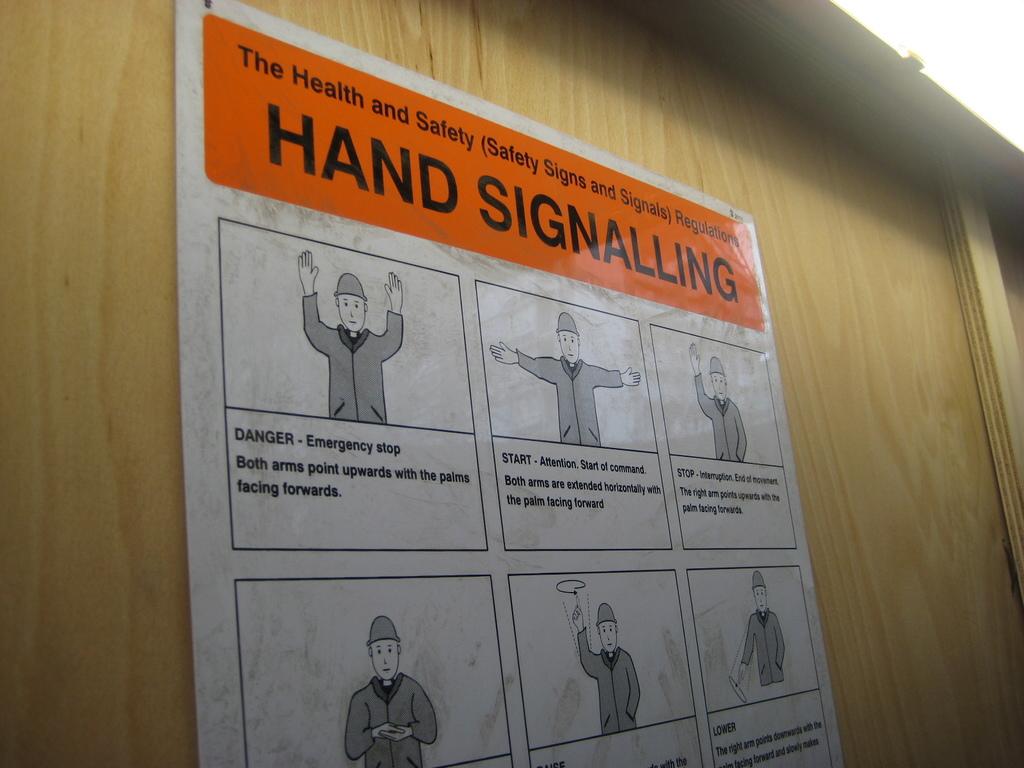What does this poster show you how to do?
Make the answer very short. Hand signalling. What does palms facing forward signal?
Your answer should be very brief. Danger. 